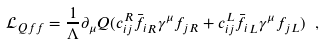<formula> <loc_0><loc_0><loc_500><loc_500>\mathcal { L } _ { Q f f } = \frac { 1 } { \Lambda } \partial _ { \mu } Q ( c _ { i j } ^ { R } \bar { f _ { i } } _ { R } \gamma ^ { \mu } f _ { j R } + c _ { i j } ^ { L } \bar { f _ { i } } _ { L } \gamma ^ { \mu } f _ { j L } ) \ ,</formula> 